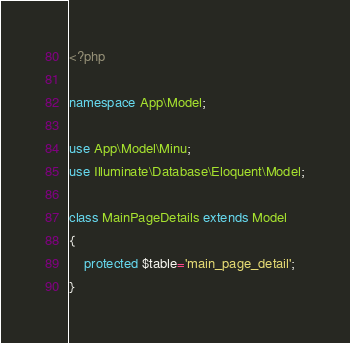<code> <loc_0><loc_0><loc_500><loc_500><_PHP_><?php

namespace App\Model;

use App\Model\Minu;
use Illuminate\Database\Eloquent\Model;

class MainPageDetails extends Model
{
    protected $table='main_page_detail';
}
</code> 